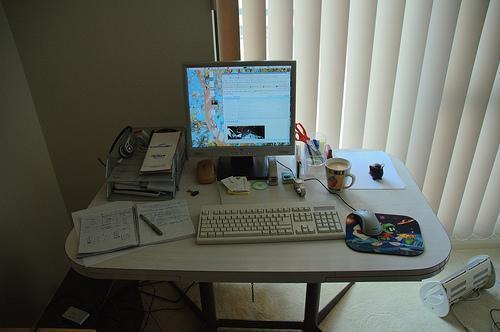How many computers are there?
Give a very brief answer. 1. 